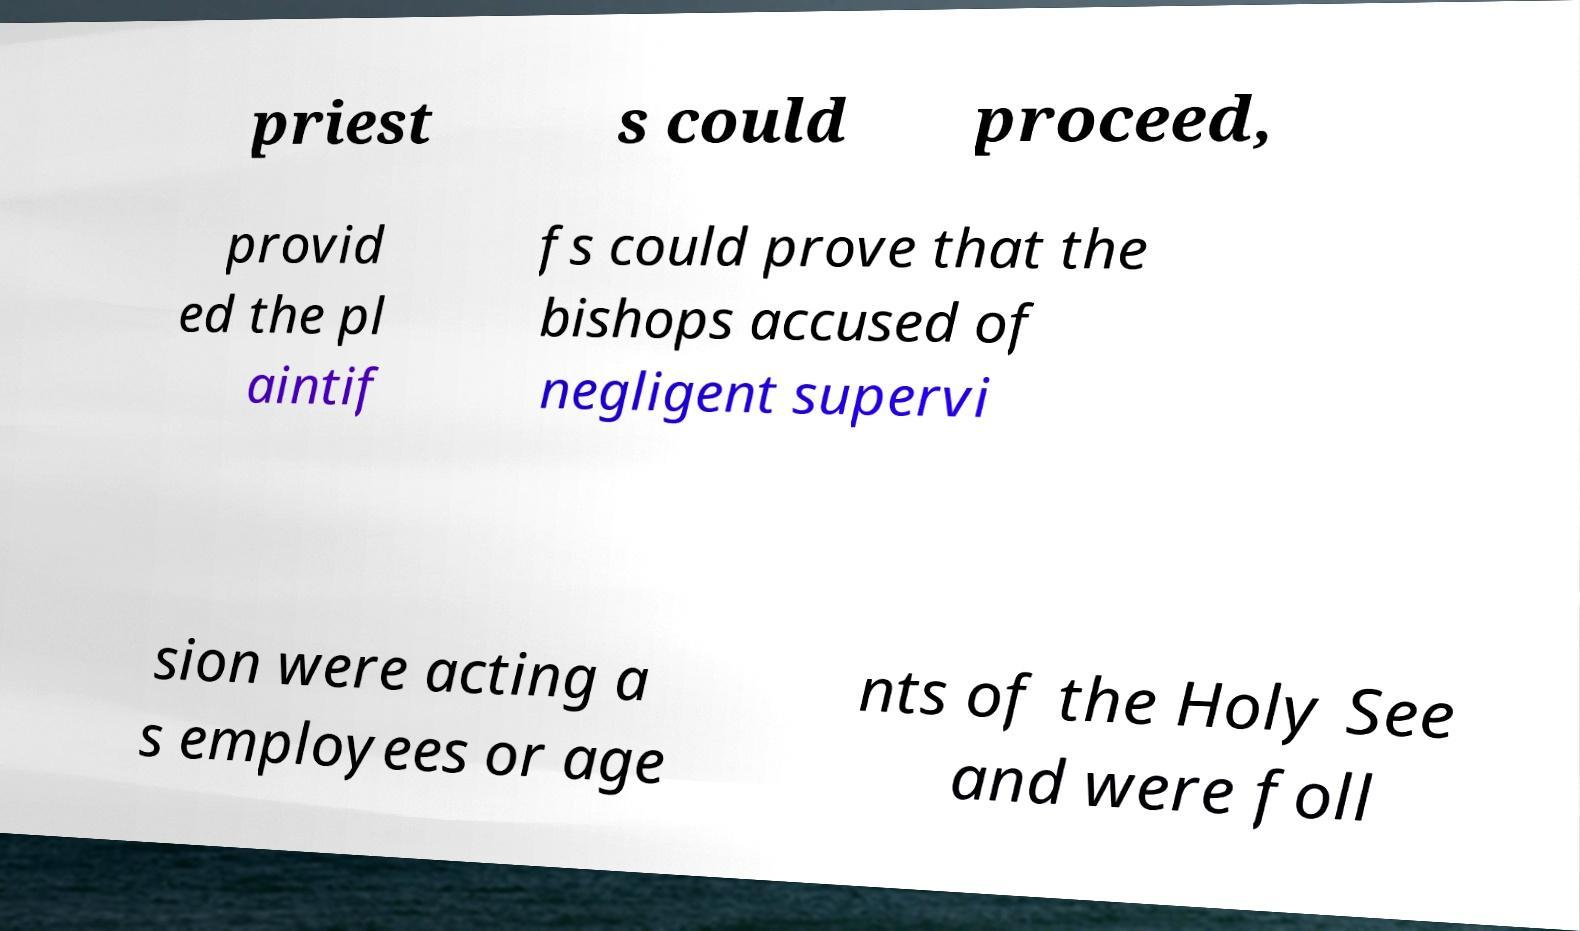Could you assist in decoding the text presented in this image and type it out clearly? priest s could proceed, provid ed the pl aintif fs could prove that the bishops accused of negligent supervi sion were acting a s employees or age nts of the Holy See and were foll 